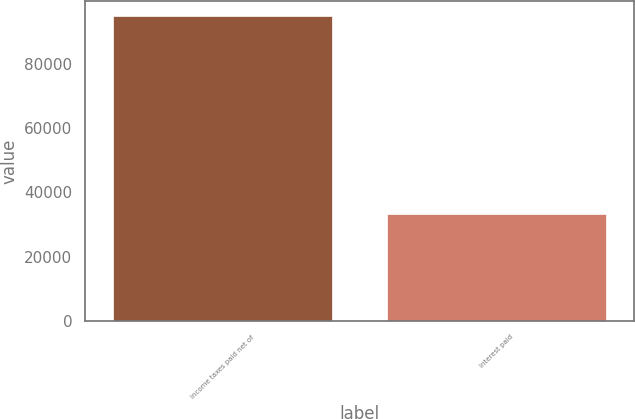Convert chart to OTSL. <chart><loc_0><loc_0><loc_500><loc_500><bar_chart><fcel>Income taxes paid net of<fcel>Interest paid<nl><fcel>94938<fcel>33214<nl></chart> 